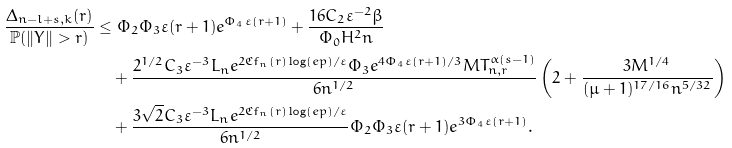Convert formula to latex. <formula><loc_0><loc_0><loc_500><loc_500>\frac { \Delta _ { n - l + s , k } ( r ) } { \mathbb { P } ( \| Y \| > r ) } & \leq \Phi _ { 2 } \Phi _ { 3 } \varepsilon ( r + 1 ) e ^ { \Phi _ { 4 } \varepsilon ( r + 1 ) } + \frac { 1 6 C _ { 2 } \varepsilon ^ { - 2 } \beta } { \Phi _ { 0 } H ^ { 2 } n } \\ & \quad + \frac { { 2 } ^ { 1 / 2 } C _ { 3 } \varepsilon ^ { - 3 } L _ { n } e ^ { 2 \mathfrak { C } f _ { n } ( r ) \log ( e p ) / \varepsilon } \Phi _ { 3 } e ^ { 4 \Phi _ { 4 } \varepsilon ( r + 1 ) / 3 } M T _ { n , r } ^ { \alpha ( s - 1 ) } } { 6 n ^ { 1 / 2 } } \left ( 2 + \frac { 3 M ^ { 1 / 4 } } { ( \mu + 1 ) ^ { 1 7 / 1 6 } n ^ { 5 / 3 2 } } \right ) \\ & \quad + \frac { 3 \sqrt { 2 } C _ { 3 } \varepsilon ^ { - 3 } L _ { n } e ^ { 2 \mathfrak { C } f _ { n } ( r ) \log ( e p ) / \varepsilon } } { 6 n ^ { 1 / 2 } } \Phi _ { 2 } \Phi _ { 3 } \varepsilon ( r + 1 ) e ^ { 3 \Phi _ { 4 } \varepsilon ( r + 1 ) } .</formula> 